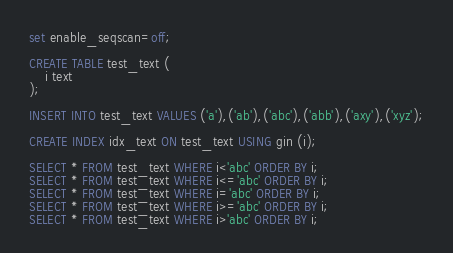<code> <loc_0><loc_0><loc_500><loc_500><_SQL_>set enable_seqscan=off;

CREATE TABLE test_text (
	i text
);

INSERT INTO test_text VALUES ('a'),('ab'),('abc'),('abb'),('axy'),('xyz');

CREATE INDEX idx_text ON test_text USING gin (i);

SELECT * FROM test_text WHERE i<'abc' ORDER BY i;
SELECT * FROM test_text WHERE i<='abc' ORDER BY i;
SELECT * FROM test_text WHERE i='abc' ORDER BY i;
SELECT * FROM test_text WHERE i>='abc' ORDER BY i;
SELECT * FROM test_text WHERE i>'abc' ORDER BY i;
</code> 